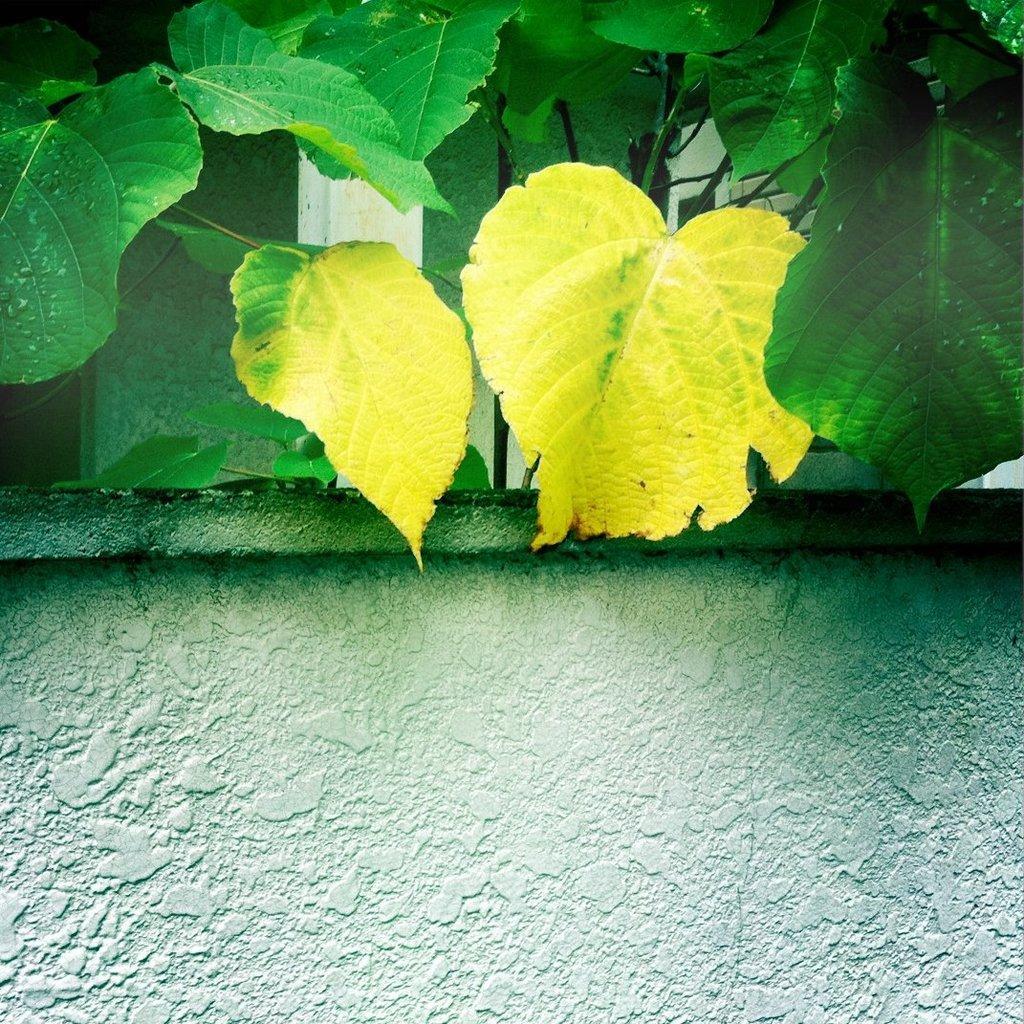In one or two sentences, can you explain what this image depicts? As we can see in the image there is a wall and plants. 